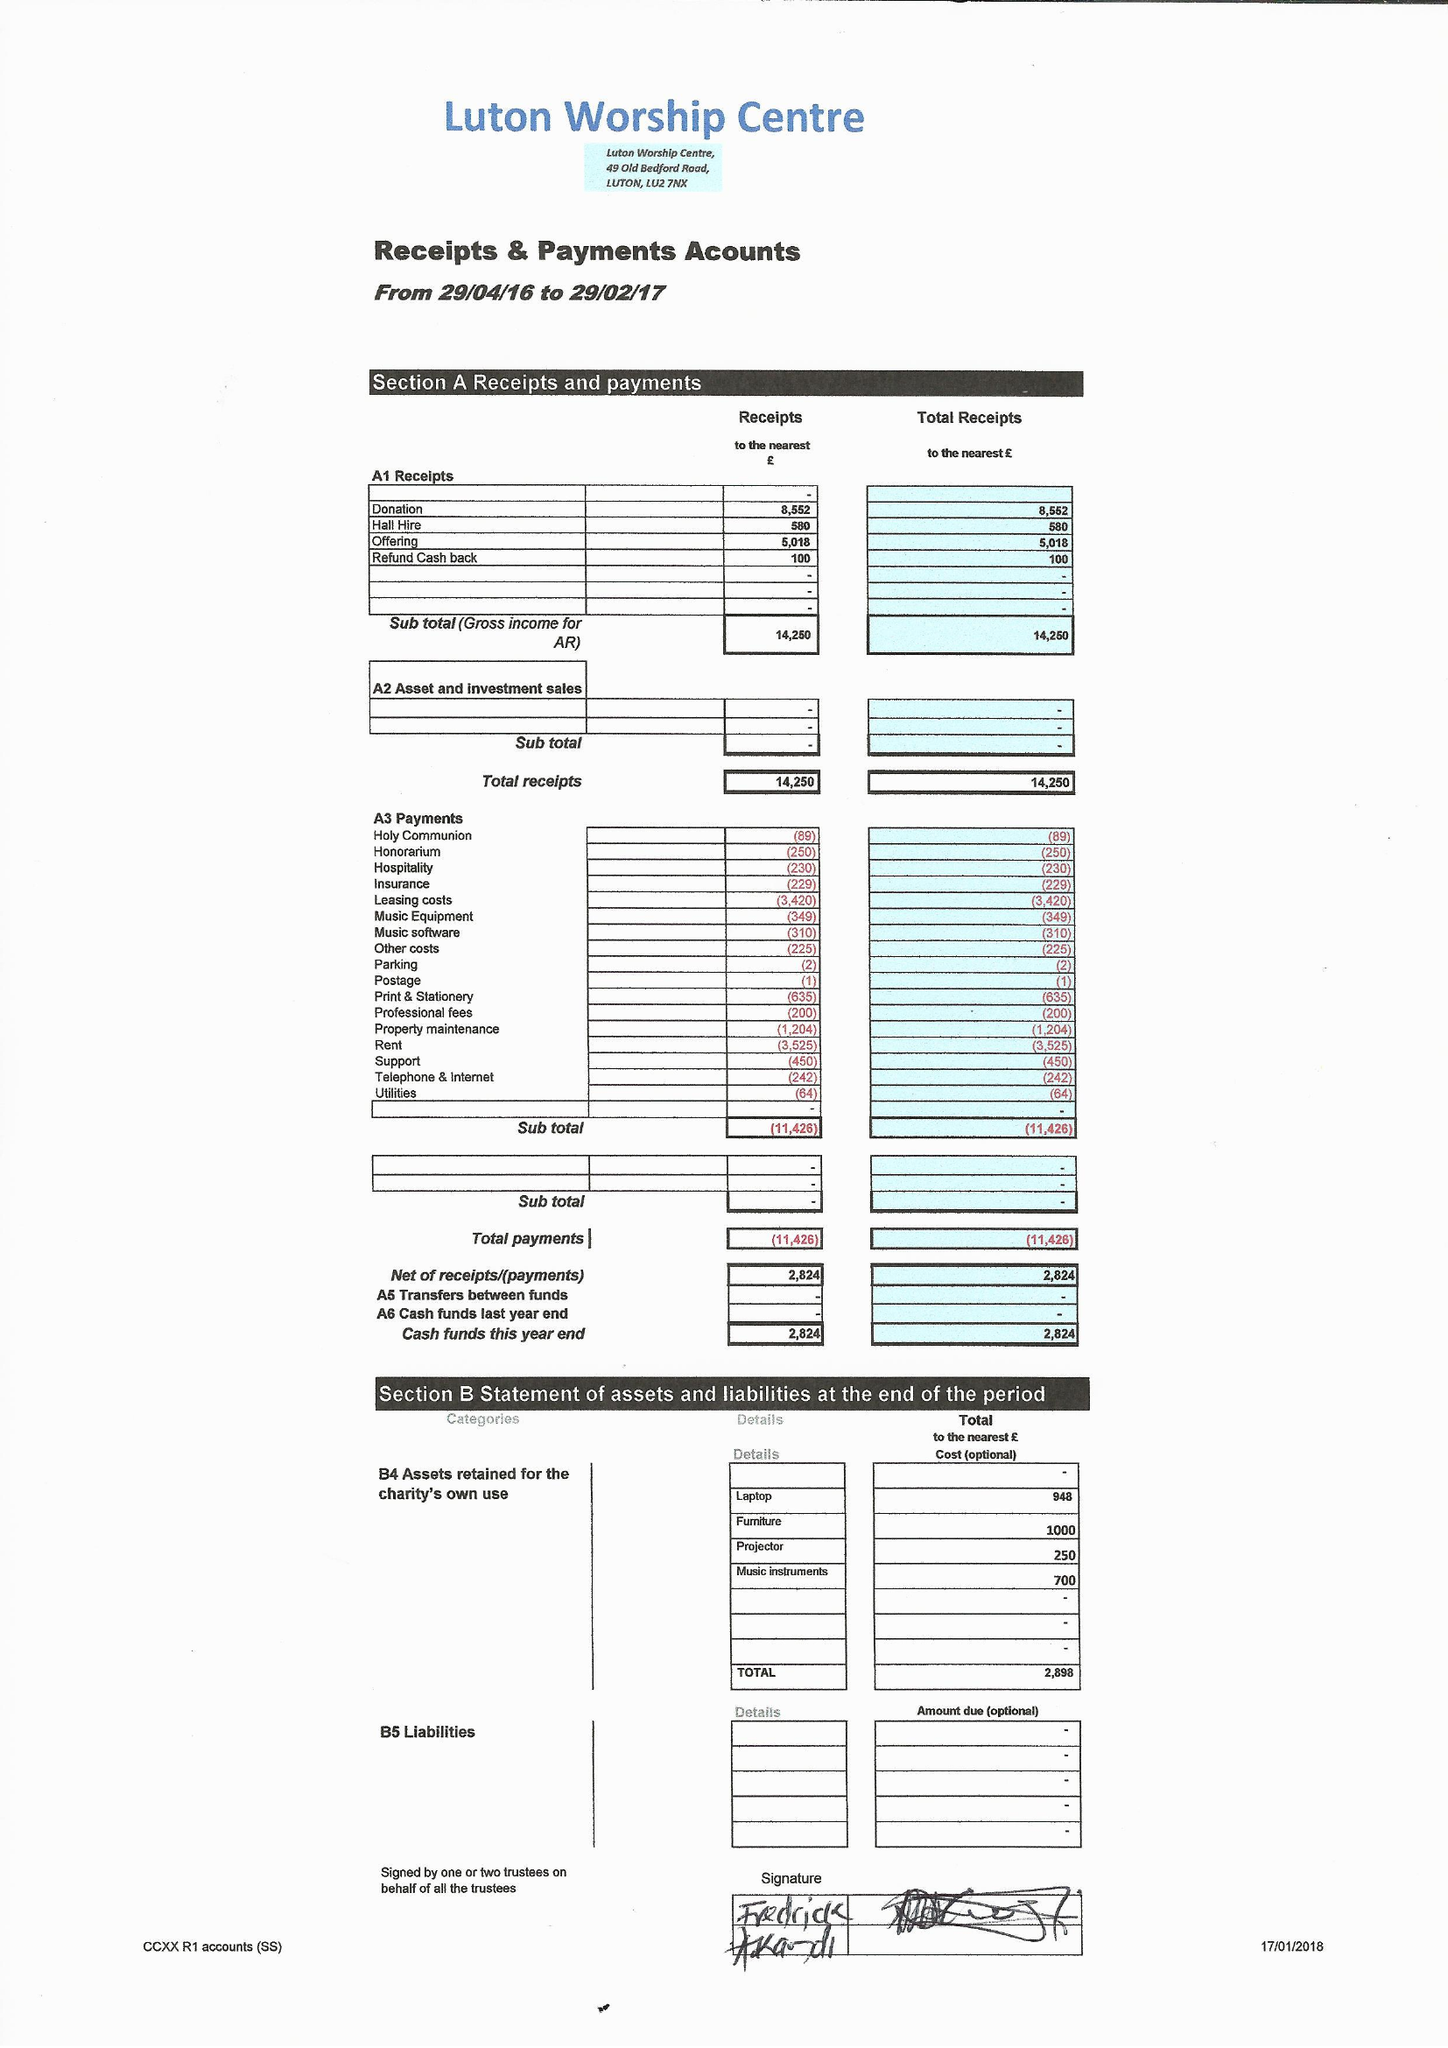What is the value for the address__postcode?
Answer the question using a single word or phrase. LU2 7NX 